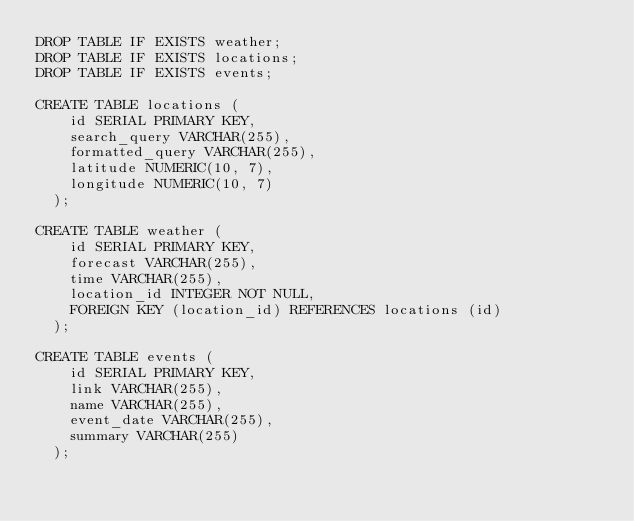<code> <loc_0><loc_0><loc_500><loc_500><_SQL_>DROP TABLE IF EXISTS weather;
DROP TABLE IF EXISTS locations;
DROP TABLE IF EXISTS events;

CREATE TABLE locations ( 
    id SERIAL PRIMARY KEY, 
    search_query VARCHAR(255), 
    formatted_query VARCHAR(255), 
    latitude NUMERIC(10, 7), 
    longitude NUMERIC(10, 7)
  );

CREATE TABLE weather ( 
    id SERIAL PRIMARY KEY, 
    forecast VARCHAR(255), 
    time VARCHAR(255), 
    location_id INTEGER NOT NULL,
    FOREIGN KEY (location_id) REFERENCES locations (id)
  );

CREATE TABLE events (
    id SERIAL PRIMARY KEY,
    link VARCHAR(255),
    name VARCHAR(255),
    event_date VARCHAR(255),
    summary VARCHAR(255)
  );
</code> 